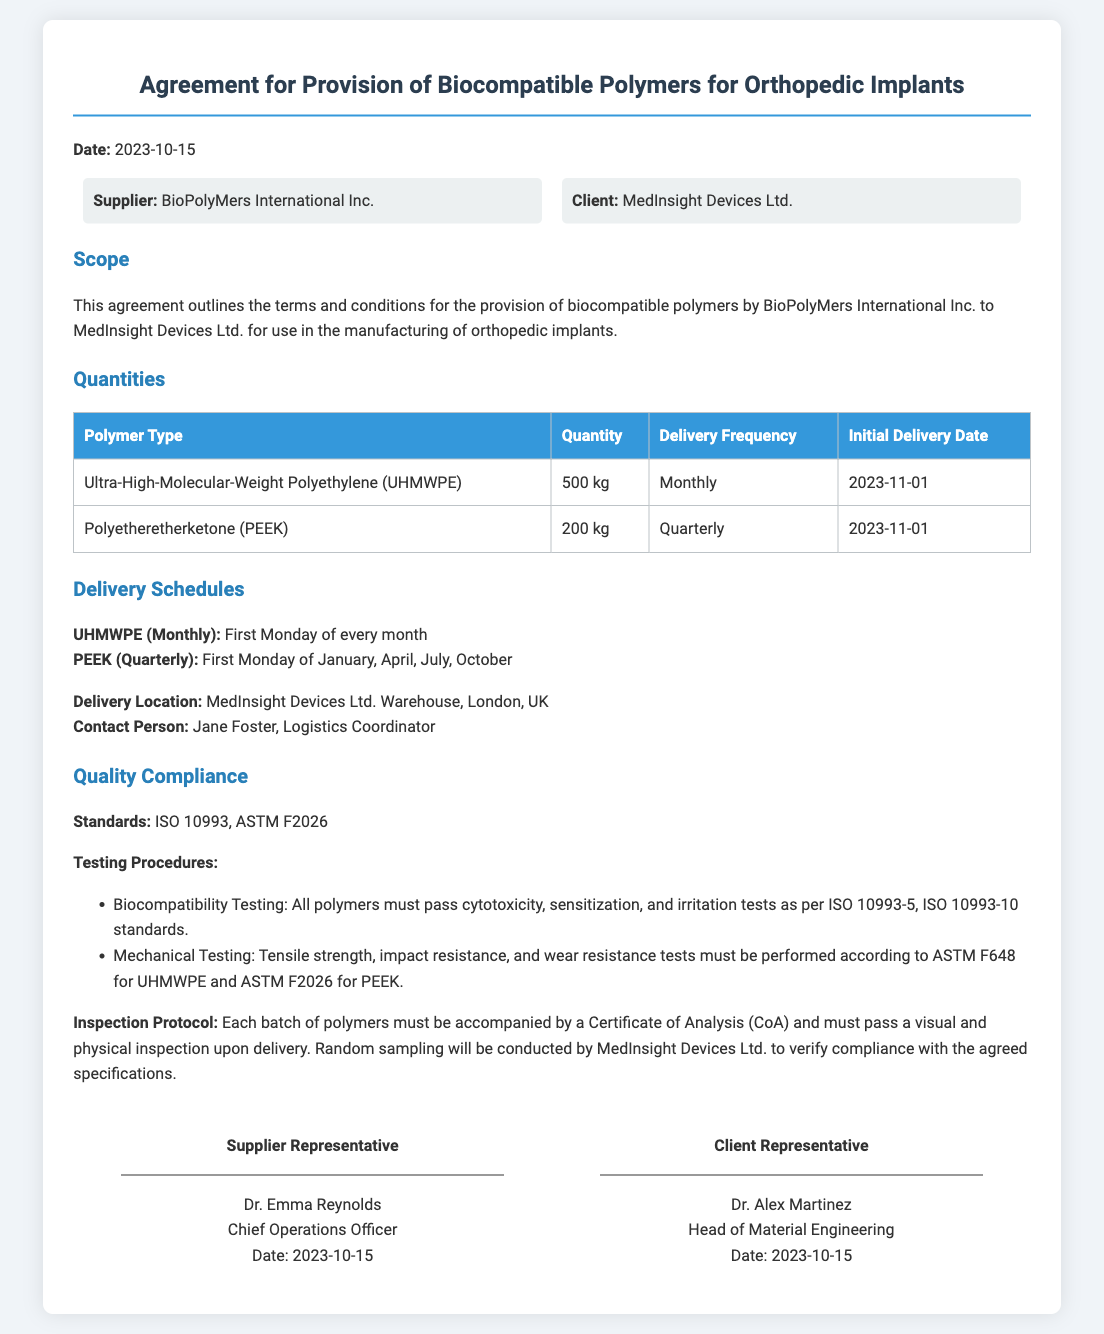What is the name of the supplier? The name of the supplier is provided in the parties section of the document.
Answer: BioPolyMers International Inc What is the quantity of Polyetheretherketone (PEEK) to be delivered? The quantity for PEEK is mentioned in the quantities table of the document.
Answer: 200 kg When is the first delivery date for UHMWPE? The initial delivery date for UHMWPE is specified in the quantities section of the document.
Answer: 2023-11-01 What is the delivery frequency for UHMWPE? The delivery frequency for UHMWPE is indicated in the quantities table.
Answer: Monthly Which standards must the polymers comply with? The compliance standards are listed in the quality compliance section of the document.
Answer: ISO 10993, ASTM F2026 Who is the contact person for deliveries? The contact person's name is mentioned in the delivery schedules section.
Answer: Jane Foster What testing must be performed for mechanical properties of UHMWPE? The relevant testing procedures for UHMWPE are detailed in the quality compliance section.
Answer: Tensile strength, impact resistance, wear resistance What is required for inspection upon delivery? The inspection measures are described in the quality compliance section.
Answer: Certificate of Analysis (CoA) and visual/physical inspection 